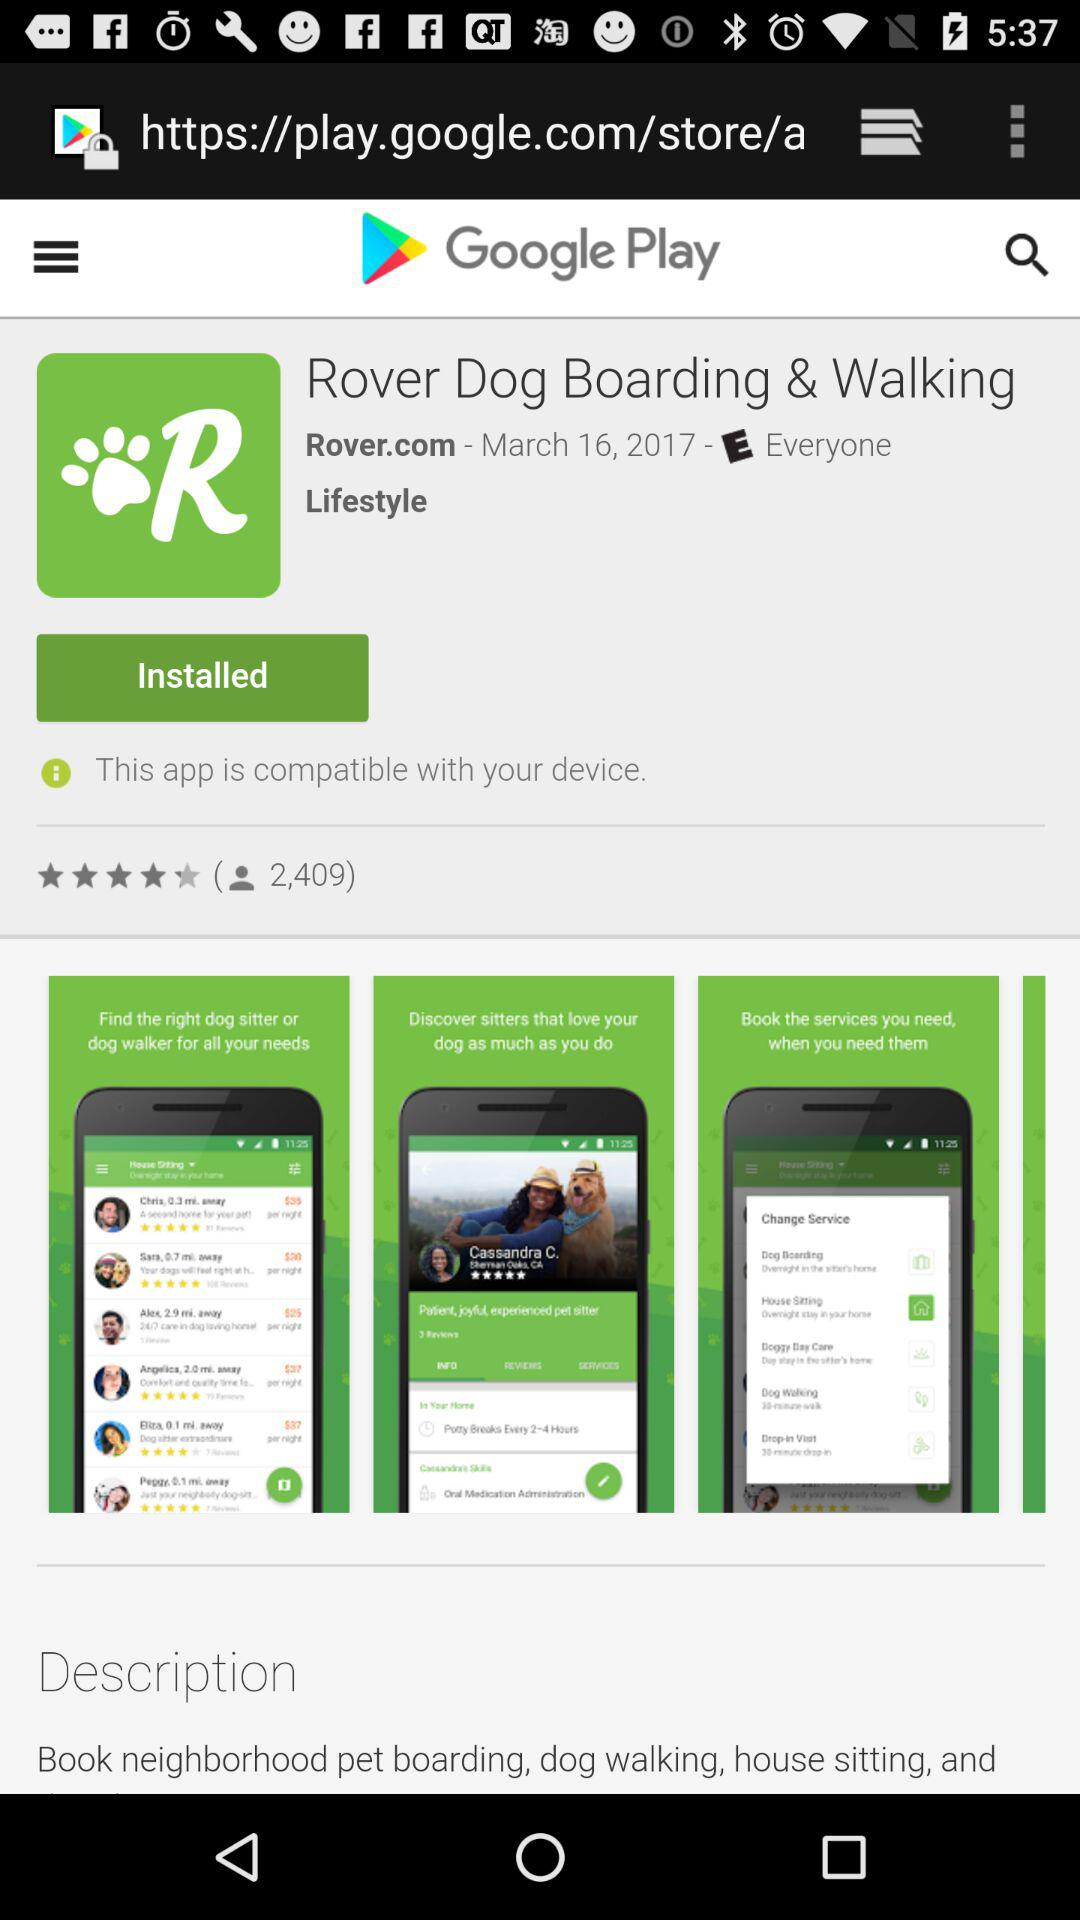What is the application name? The application name is "Rover Dog Boarding & Walking". 